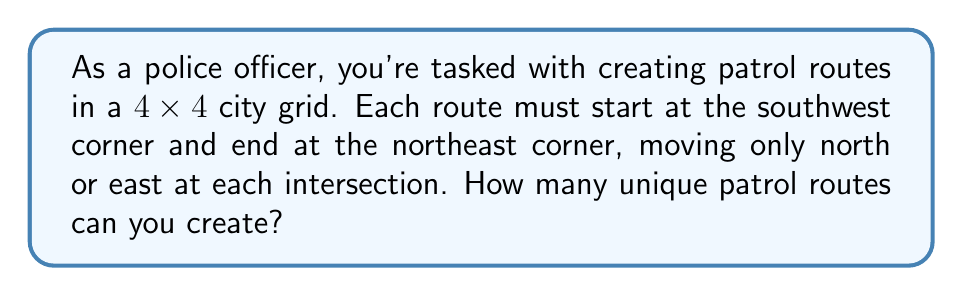Show me your answer to this math problem. Let's approach this step-by-step:

1) First, we need to understand what the question is asking. We're looking for the number of paths from one corner of a 4x4 grid to the opposite corner, moving only right or up.

2) This is a classic combinatorics problem. To reach the northeast corner from the southwest corner, we must make 4 moves east and 4 moves north, in any order.

3) The total number of moves is always 8 (4 east + 4 north).

4) The question is essentially asking: in how many ways can we arrange 4 east moves and 4 north moves in a sequence of 8 moves?

5) This is equivalent to choosing which 4 of the 8 moves will be "east" moves (or equivalently, which 4 will be "north" moves).

6) In combinatorics, this is known as a combination problem. We can calculate it using the formula:

   $$\binom{n}{k} = \frac{n!}{k!(n-k)!}$$

   Where $n$ is the total number of moves (8) and $k$ is the number of east (or north) moves (4).

7) Plugging in the numbers:

   $$\binom{8}{4} = \frac{8!}{4!(8-4)!} = \frac{8!}{4!4!}$$

8) Calculating this out:

   $$\frac{8 * 7 * 6 * 5 * 4!}{4! * 4 * 3 * 2 * 1} = \frac{1680}{24} = 70$$

Therefore, there are 70 unique patrol routes possible.
Answer: 70 